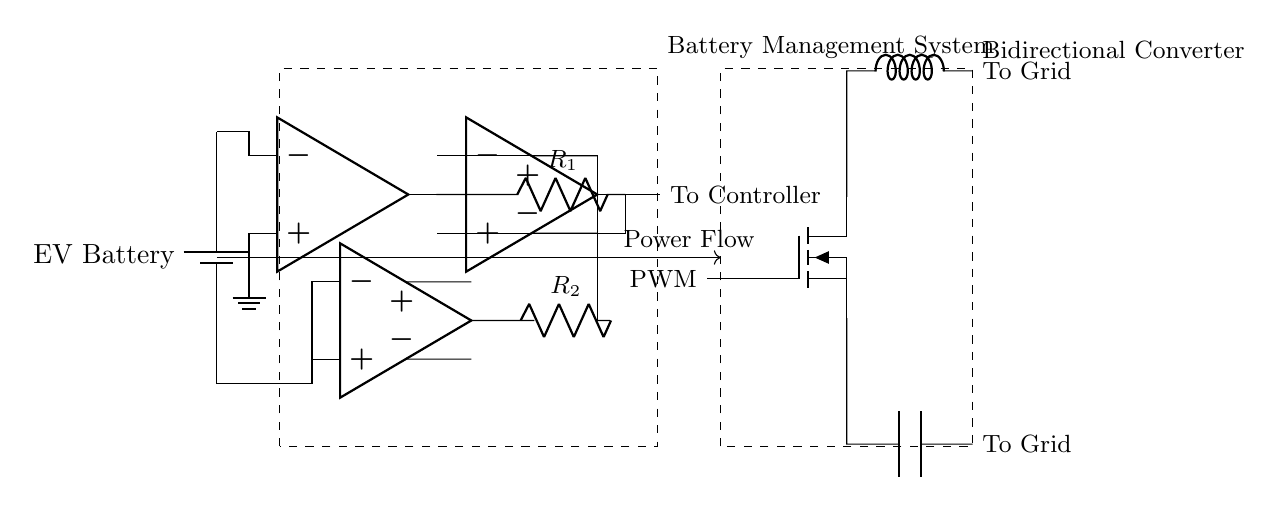What is the main function of the Battery Management System? The Battery Management System (BMS) is responsible for monitoring and managing the battery pack's performance, which includes voltage and current sensing to ensure safe and effective operation.
Answer: Monitoring and management What type of sensor is used for voltage sensing? The voltage sensing is performed using a field-effect operational amplifier (fd op amp), as indicated by the specific component labeled in the circuit diagram.
Answer: Field-effect operational amplifier What component connects the battery to the grid? The bidirectional converter is the component connecting the battery system to the grid, allowing power flow in both directions for charging and discharging.
Answer: Bidirectional converter How many resistors are present in the circuit? There are two resistors in the circuit, labeled R1 and R2, which are used in conjunction with the voltage and current sensing components.
Answer: Two Explain the role of the op-amp in the circuit. The operational amplifier serves as a voltage comparator in the BMS, ensuring that the battery voltage is at safe levels by comparing the input voltage to a reference voltage. The output then informs the system of any necessary adjustments or alerts.
Answer: Voltage comparator What does the dashed line represent in the circuit diagram? The dashed lines outline the components of the Battery Management System and the Bidirectional Converter, indicating enclosed functional units within the overall circuit structure for clarity.
Answer: Enclosed functional units 